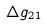Convert formula to latex. <formula><loc_0><loc_0><loc_500><loc_500>\Delta g _ { 2 1 }</formula> 